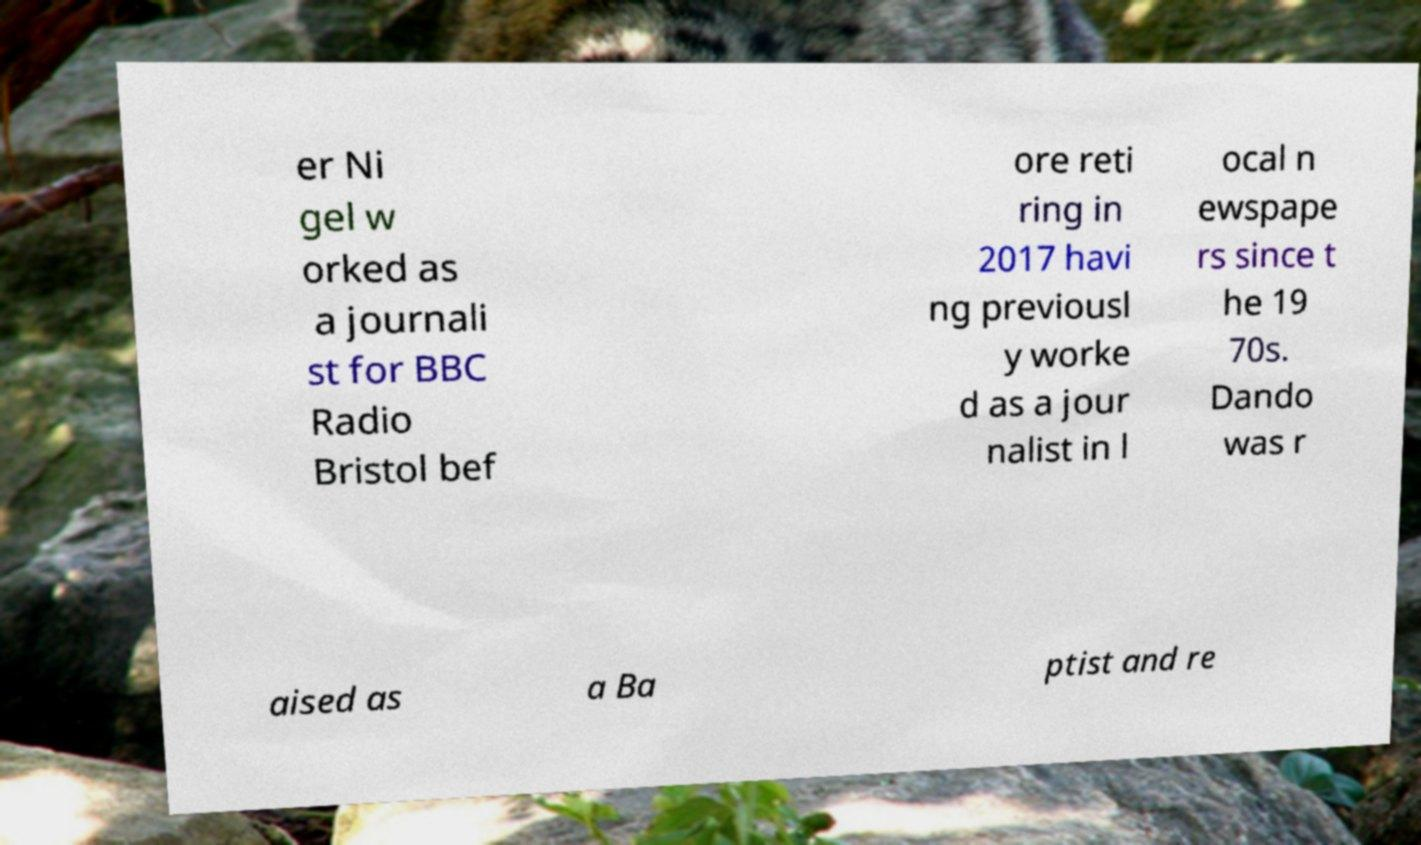There's text embedded in this image that I need extracted. Can you transcribe it verbatim? er Ni gel w orked as a journali st for BBC Radio Bristol bef ore reti ring in 2017 havi ng previousl y worke d as a jour nalist in l ocal n ewspape rs since t he 19 70s. Dando was r aised as a Ba ptist and re 